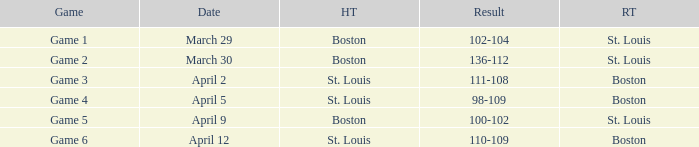What is the date for game 3 involving boston visiting team? April 2. 